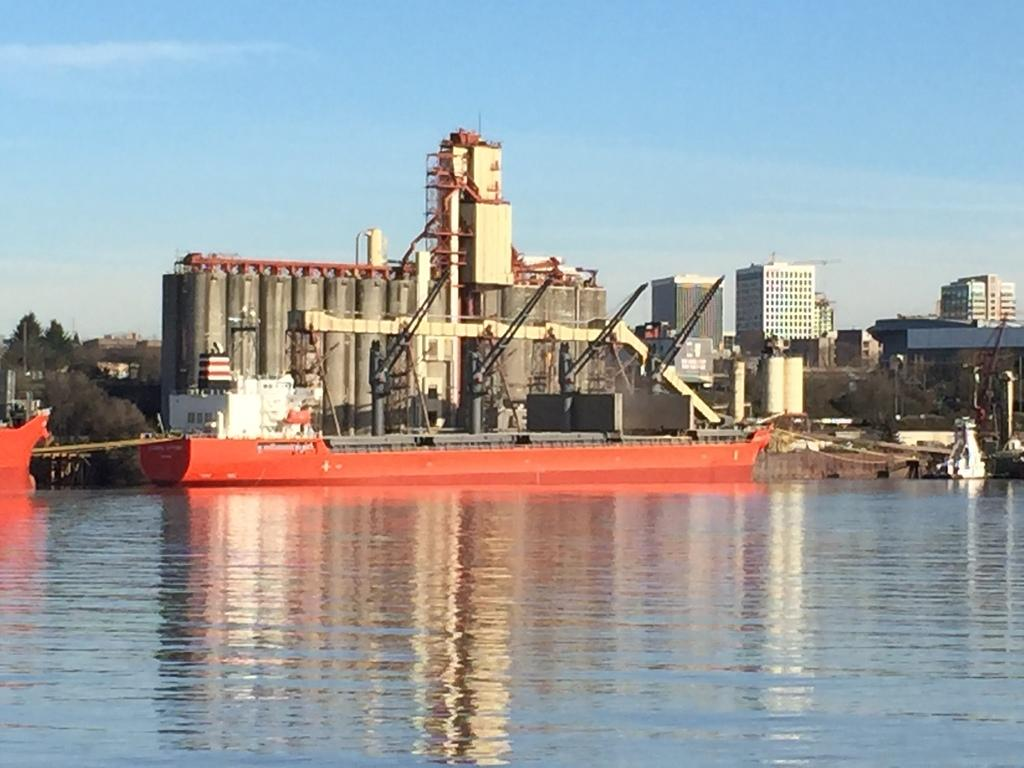What is the main subject of the image? The main subject of the image is a ship. Can you describe the ship's position in relation to the water? The ship is above the water in the image. What can be seen in the background of the image? There are buildings, trees, cranes, and the sky visible in the background of the image. What type of zinc is being used to build the ship in the image? There is no information about the materials used to build the ship in the image. Can you tell me the name of the daughter of the ship's captain in the image? There is no information about the ship's captain or any passengers in the image. 